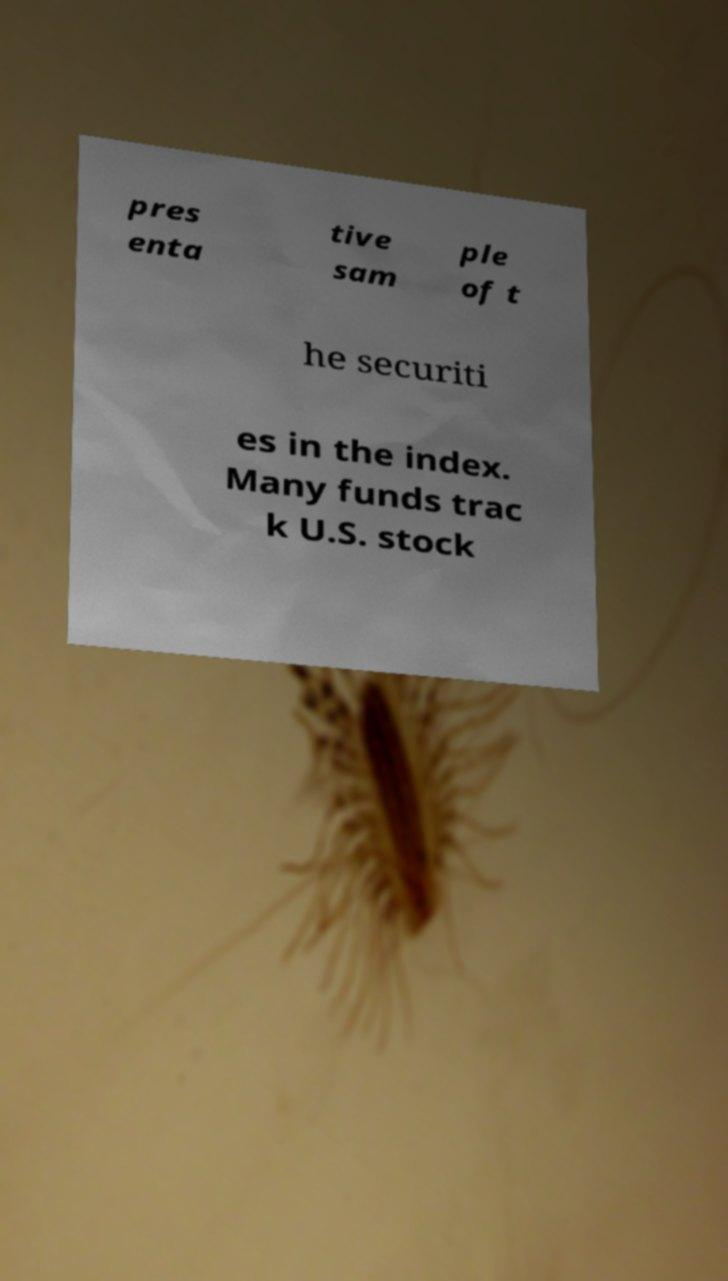Can you accurately transcribe the text from the provided image for me? pres enta tive sam ple of t he securiti es in the index. Many funds trac k U.S. stock 